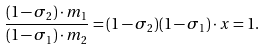Convert formula to latex. <formula><loc_0><loc_0><loc_500><loc_500>\frac { ( 1 - \sigma _ { 2 } ) \cdot m _ { 1 } } { ( 1 - \sigma _ { 1 } ) \cdot m _ { 2 } } = ( 1 - \sigma _ { 2 } ) ( 1 - \sigma _ { 1 } ) \cdot x = 1 .</formula> 